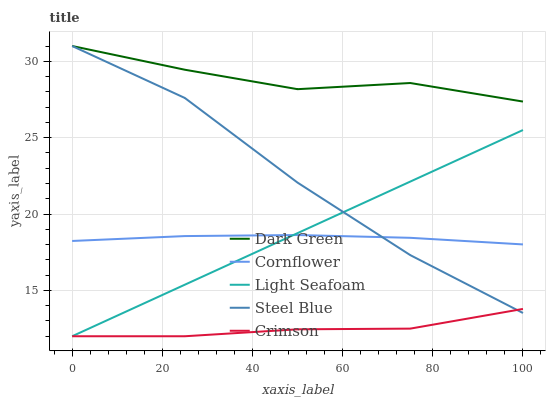Does Crimson have the minimum area under the curve?
Answer yes or no. Yes. Does Dark Green have the maximum area under the curve?
Answer yes or no. Yes. Does Cornflower have the minimum area under the curve?
Answer yes or no. No. Does Cornflower have the maximum area under the curve?
Answer yes or no. No. Is Light Seafoam the smoothest?
Answer yes or no. Yes. Is Steel Blue the roughest?
Answer yes or no. Yes. Is Cornflower the smoothest?
Answer yes or no. No. Is Cornflower the roughest?
Answer yes or no. No. Does Crimson have the lowest value?
Answer yes or no. Yes. Does Cornflower have the lowest value?
Answer yes or no. No. Does Dark Green have the highest value?
Answer yes or no. Yes. Does Cornflower have the highest value?
Answer yes or no. No. Is Crimson less than Cornflower?
Answer yes or no. Yes. Is Dark Green greater than Crimson?
Answer yes or no. Yes. Does Light Seafoam intersect Steel Blue?
Answer yes or no. Yes. Is Light Seafoam less than Steel Blue?
Answer yes or no. No. Is Light Seafoam greater than Steel Blue?
Answer yes or no. No. Does Crimson intersect Cornflower?
Answer yes or no. No. 